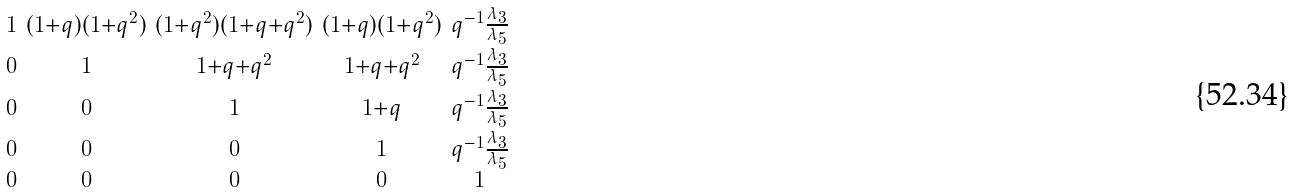Convert formula to latex. <formula><loc_0><loc_0><loc_500><loc_500>\begin{smallmatrix} 1 & ( 1 + q ) ( 1 + q ^ { 2 } ) & ( 1 + q ^ { 2 } ) ( 1 + q + q ^ { 2 } ) & ( 1 + q ) ( 1 + q ^ { 2 } ) & q ^ { - 1 } \frac { \lambda _ { 3 } } { \lambda _ { 5 } } \\ 0 & 1 & 1 + q + q ^ { 2 } & 1 + q + q ^ { 2 } & q ^ { - 1 } \frac { \lambda _ { 3 } } { \lambda _ { 5 } } \\ 0 & 0 & 1 & 1 + q & q ^ { - 1 } \frac { \lambda _ { 3 } } { \lambda _ { 5 } } \\ 0 & 0 & 0 & 1 & q ^ { - 1 } \frac { \lambda _ { 3 } } { \lambda _ { 5 } } \\ 0 & 0 & 0 & 0 & 1 \end{smallmatrix}</formula> 